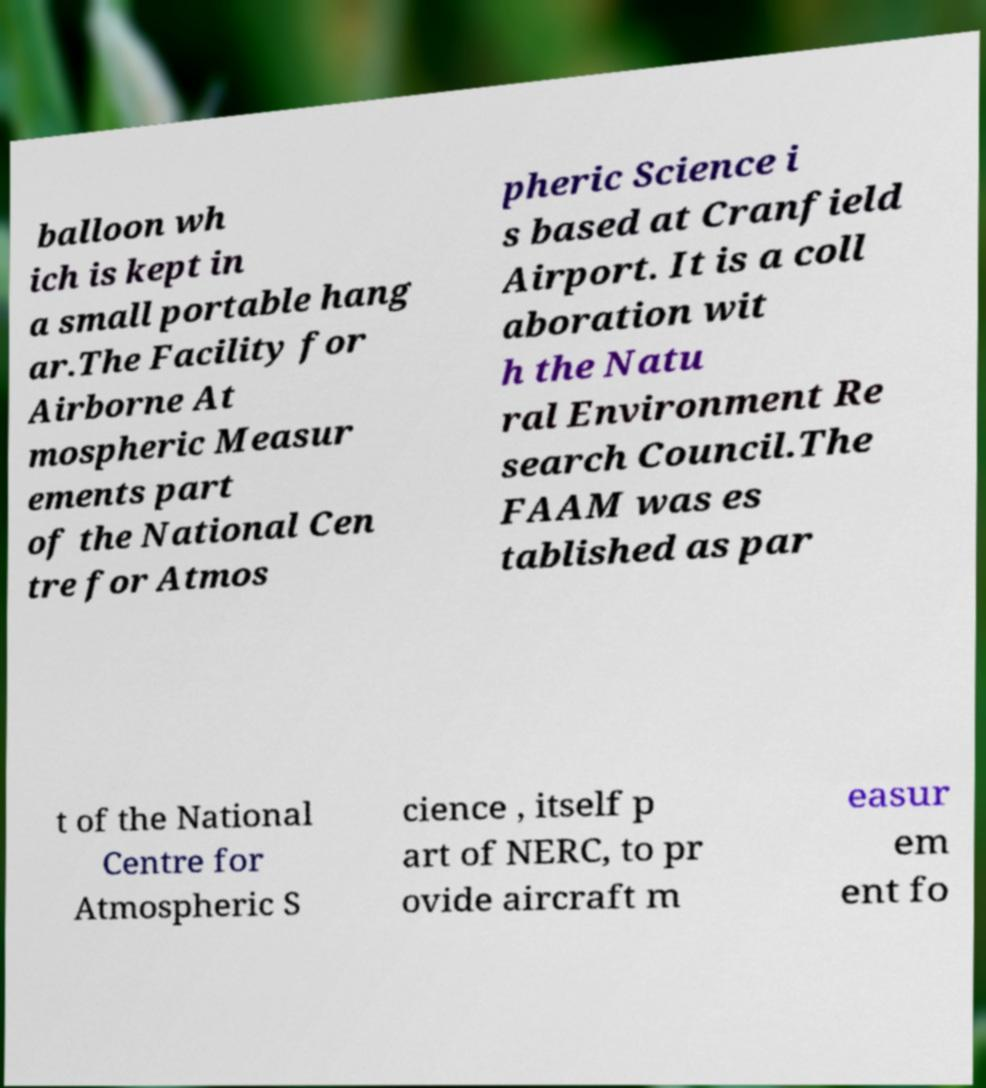Can you accurately transcribe the text from the provided image for me? balloon wh ich is kept in a small portable hang ar.The Facility for Airborne At mospheric Measur ements part of the National Cen tre for Atmos pheric Science i s based at Cranfield Airport. It is a coll aboration wit h the Natu ral Environment Re search Council.The FAAM was es tablished as par t of the National Centre for Atmospheric S cience , itself p art of NERC, to pr ovide aircraft m easur em ent fo 